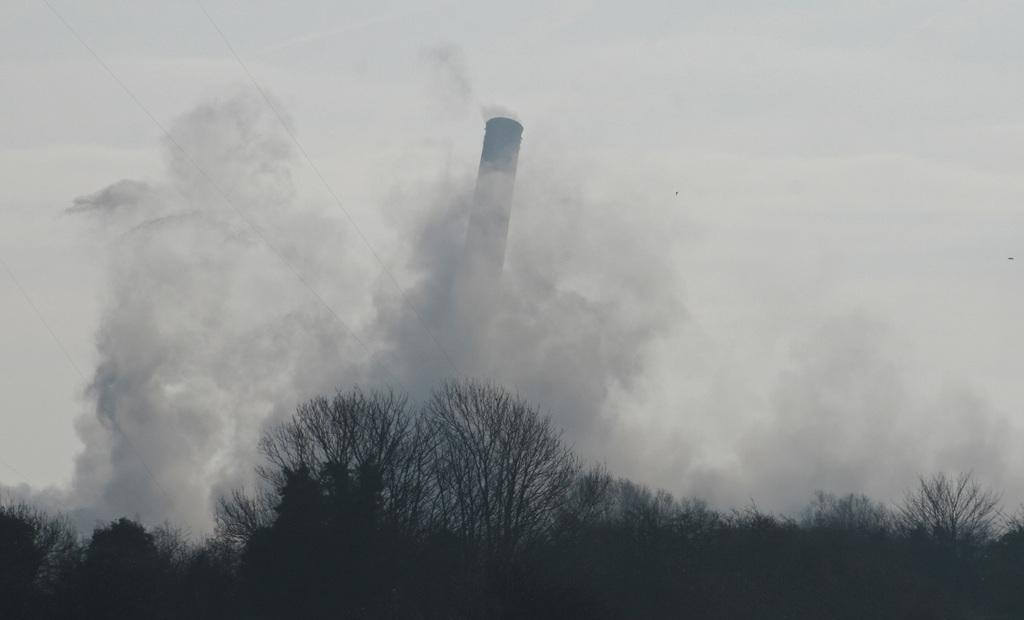What type of vegetation can be seen in the image? There are trees in the image. What structure is located in the middle of the image? There is a smoke tower in the middle of the image. What is visible in the background of the image? The sky is visible in the background of the image. What type of paste is being used to construct the smoke tower in the image? There is no indication of any paste being used in the construction of the smoke tower in the image. What role does the calculator play in the image? There is no calculator present in the image. 